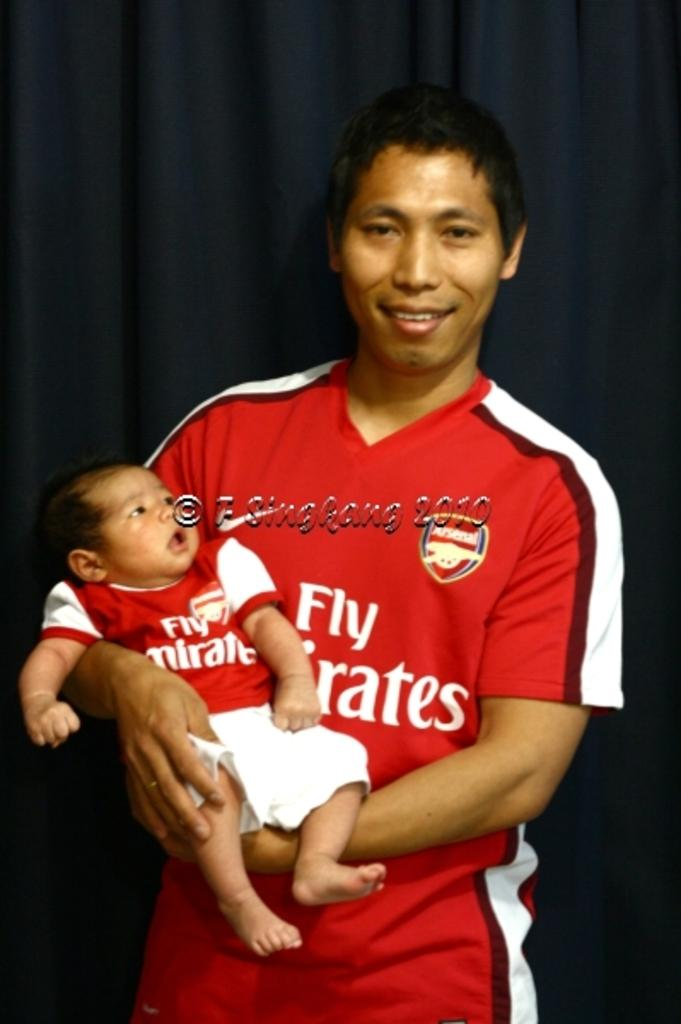<image>
Render a clear and concise summary of the photo. A man is holding a baby and wearing matching Fly Emirates jerseys. 